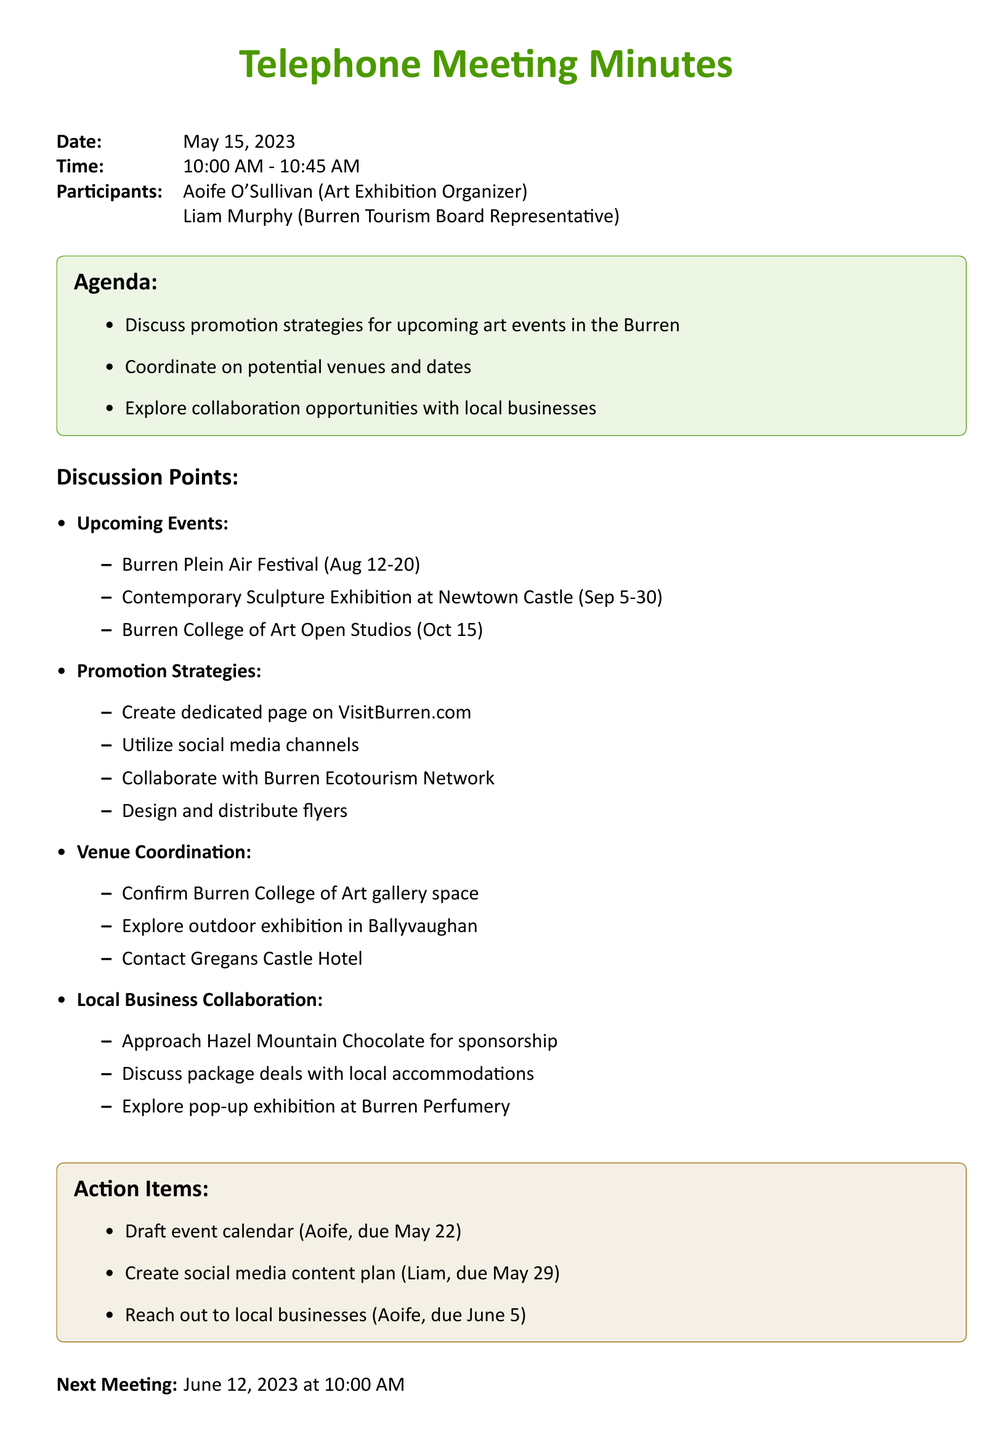What is the date of the meeting? The date of the meeting is clearly stated at the beginning of the document: May 15, 2023.
Answer: May 15, 2023 Who is the primary participant from the tourism board? The document lists Liam Murphy as the representative from the Burren Tourism Board.
Answer: Liam Murphy What event is scheduled for August? The discussion points mention the Burren Plein Air Festival taking place in August.
Answer: Burren Plein Air Festival What is one of the strategies for promoting the art events? The document lists multiple strategies, one of which is to create a dedicated page on VisitBurren.com.
Answer: Create dedicated page on VisitBurren.com What is the due date for the event calendar draft? The action items specify that the event calendar draft is due on May 22, assigned to Aoife.
Answer: May 22 Which venue is mentioned for potential outdoor exhibitions? The discussion points include exploring outdoor exhibitions in Ballyvaughan as a potential venue.
Answer: Ballyvaughan What is one suggested local business collaboration? The document includes an approach to Hazel Mountain Chocolate for sponsorship as a collaboration suggestion.
Answer: Hazel Mountain Chocolate When is the next meeting scheduled? The document indicates the next meeting is set for June 12, 2023, at 10:00 AM.
Answer: June 12, 2023 